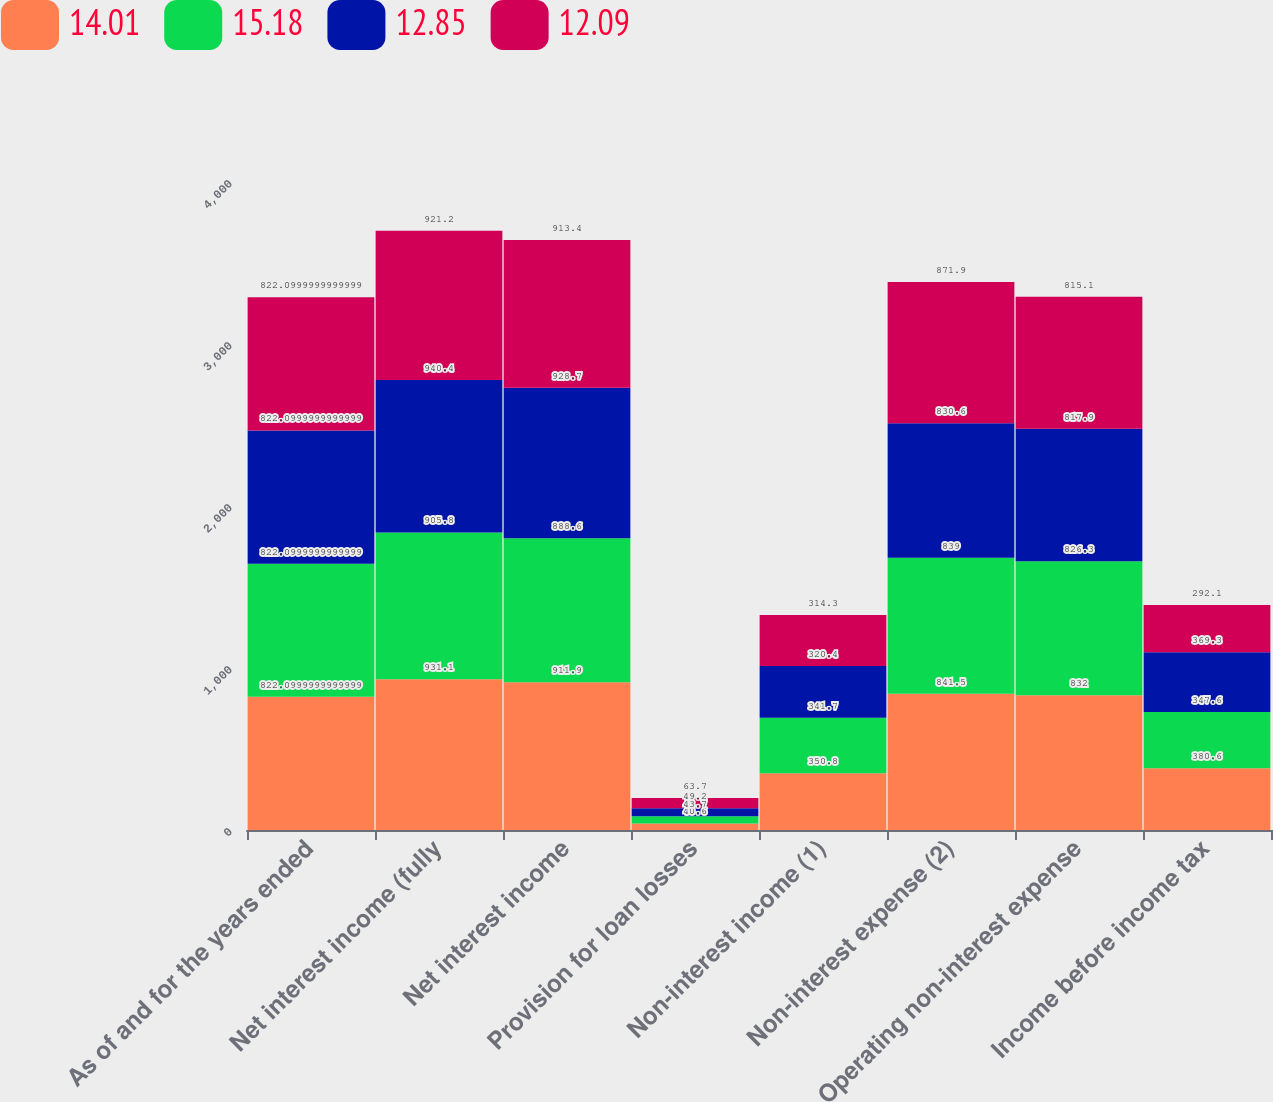Convert chart to OTSL. <chart><loc_0><loc_0><loc_500><loc_500><stacked_bar_chart><ecel><fcel>As of and for the years ended<fcel>Net interest income (fully<fcel>Net interest income<fcel>Provision for loan losses<fcel>Non-interest income (1)<fcel>Non-interest expense (2)<fcel>Operating non-interest expense<fcel>Income before income tax<nl><fcel>14.01<fcel>822.1<fcel>931.1<fcel>911.9<fcel>40.6<fcel>350.8<fcel>841.5<fcel>832<fcel>380.6<nl><fcel>15.18<fcel>822.1<fcel>905.8<fcel>888.6<fcel>43.7<fcel>341.7<fcel>839<fcel>826.3<fcel>347.6<nl><fcel>12.85<fcel>822.1<fcel>940.4<fcel>928.7<fcel>49.2<fcel>320.4<fcel>830.6<fcel>817.9<fcel>369.3<nl><fcel>12.09<fcel>822.1<fcel>921.2<fcel>913.4<fcel>63.7<fcel>314.3<fcel>871.9<fcel>815.1<fcel>292.1<nl></chart> 